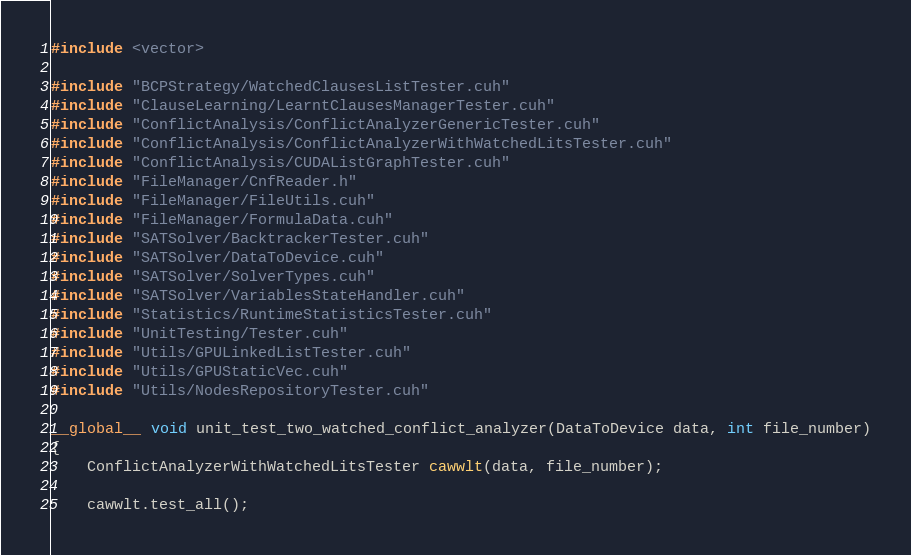<code> <loc_0><loc_0><loc_500><loc_500><_Cuda_>#include <vector>

#include "BCPStrategy/WatchedClausesListTester.cuh"
#include "ClauseLearning/LearntClausesManagerTester.cuh"
#include "ConflictAnalysis/ConflictAnalyzerGenericTester.cuh"
#include "ConflictAnalysis/ConflictAnalyzerWithWatchedLitsTester.cuh"
#include "ConflictAnalysis/CUDAListGraphTester.cuh"
#include "FileManager/CnfReader.h"
#include "FileManager/FileUtils.cuh"
#include "FileManager/FormulaData.cuh"
#include "SATSolver/BacktrackerTester.cuh"
#include "SATSolver/DataToDevice.cuh"
#include "SATSolver/SolverTypes.cuh"
#include "SATSolver/VariablesStateHandler.cuh"
#include "Statistics/RuntimeStatisticsTester.cuh"
#include "UnitTesting/Tester.cuh"
#include "Utils/GPULinkedListTester.cuh"
#include "Utils/GPUStaticVec.cuh"
#include "Utils/NodesRepositoryTester.cuh"

__global__ void unit_test_two_watched_conflict_analyzer(DataToDevice data, int file_number)
{
    ConflictAnalyzerWithWatchedLitsTester cawwlt(data, file_number);

    cawwlt.test_all();
</code> 